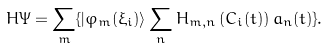<formula> <loc_0><loc_0><loc_500><loc_500>H \Psi = \sum _ { m } \{ | \varphi _ { m } ( \xi _ { i } ) \rangle \sum _ { n } { H } _ { m , n } \left ( C _ { i } ( t ) \right ) a _ { n } ( t ) \} .</formula> 